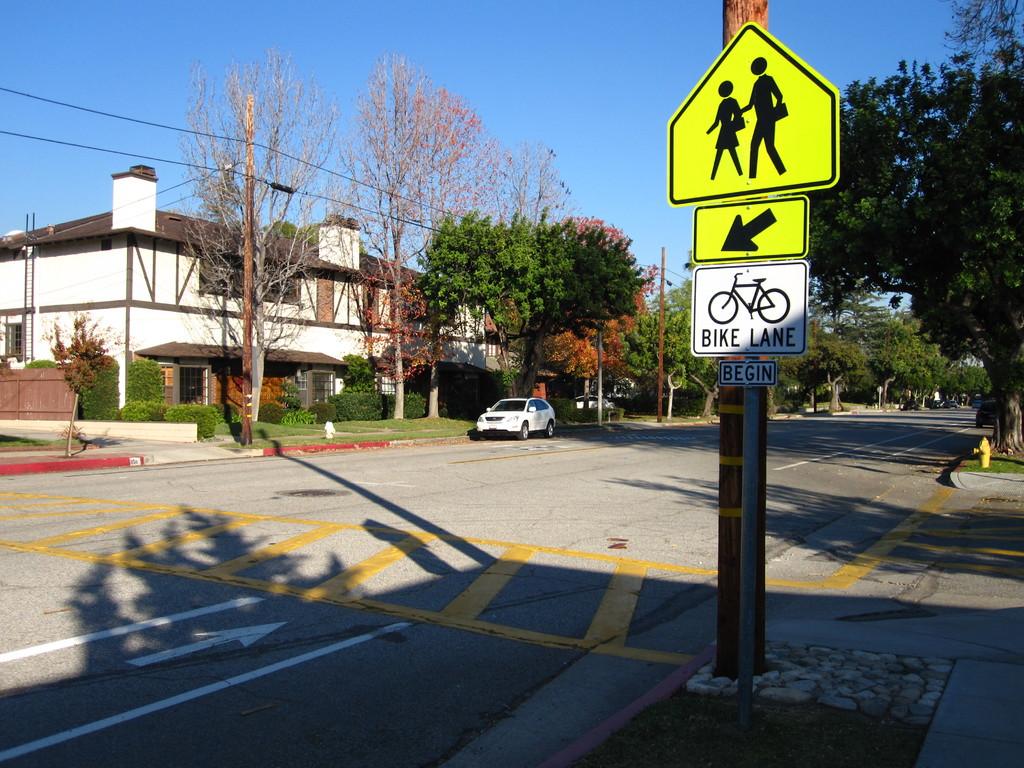What does the sign say?
Give a very brief answer. Bike lane. 